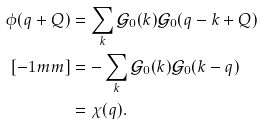Convert formula to latex. <formula><loc_0><loc_0><loc_500><loc_500>\phi ( q + Q ) & = \sum _ { k } \mathcal { G } _ { 0 } ( k ) \mathcal { G } _ { 0 } ( q - k + Q ) \\ [ - 1 m m ] & = - \sum _ { k } \mathcal { G } _ { 0 } ( k ) \mathcal { G } _ { 0 } ( k - q ) \\ & = \chi ( q ) .</formula> 